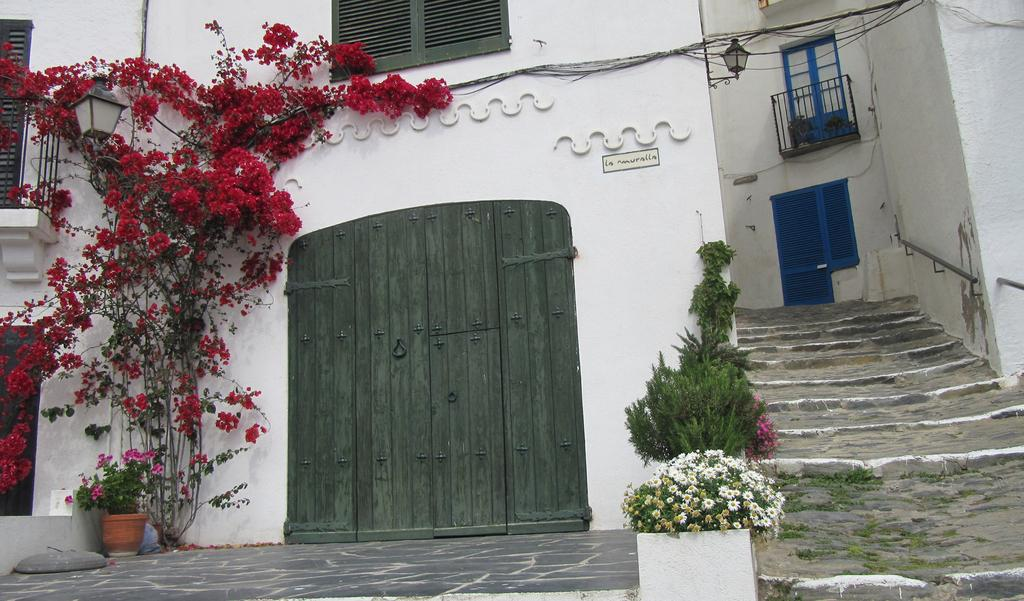What type of structure is in the image? There is a house in the image. What features can be seen on the house? The house has a window and a door. What else is present in the image besides the house? There are plants and stairs in the image. What type of lace is being used to decorate the head of the house in the image? There is no lace or head present in the image; it features a house with a window, door, plants, and stairs. What type of relation can be seen between the house and the plants in the image? The image does not depict any specific relation between the house and the plants; it simply shows the house and the plants in the same scene. 